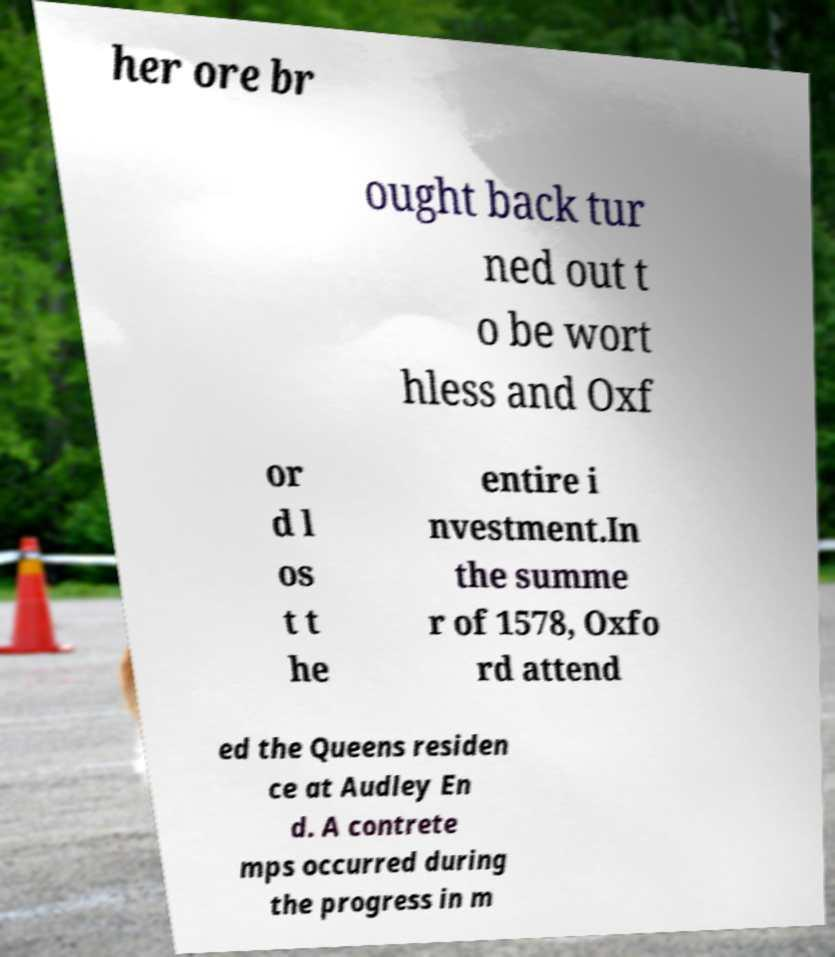Please identify and transcribe the text found in this image. her ore br ought back tur ned out t o be wort hless and Oxf or d l os t t he entire i nvestment.In the summe r of 1578, Oxfo rd attend ed the Queens residen ce at Audley En d. A contrete mps occurred during the progress in m 